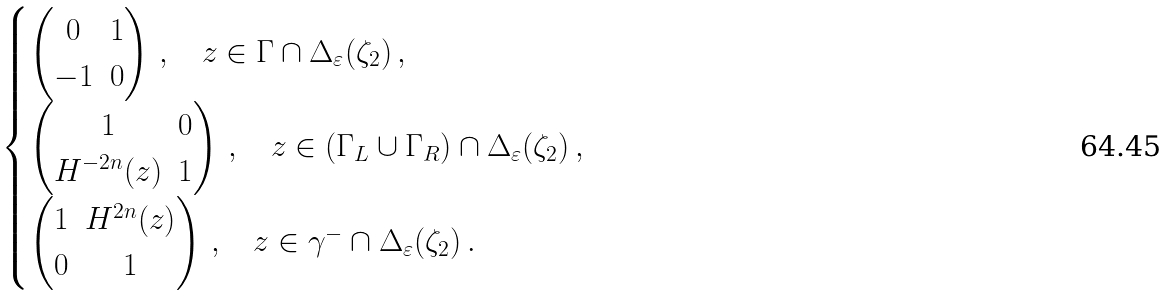Convert formula to latex. <formula><loc_0><loc_0><loc_500><loc_500>\begin{cases} \begin{pmatrix} 0 & 1 \\ - 1 & 0 \end{pmatrix} \, , \quad z \in \Gamma \cap \Delta _ { \varepsilon } ( \zeta _ { 2 } ) \, , \\ \begin{pmatrix} 1 & 0 \\ H ^ { - 2 n } ( z ) & 1 \end{pmatrix} \, , \quad z \in ( \Gamma _ { L } \cup \Gamma _ { R } ) \cap \Delta _ { \varepsilon } ( \zeta _ { 2 } ) \, , \\ \begin{pmatrix} 1 & H ^ { 2 n } ( z ) \\ 0 & 1 \end{pmatrix} \, , \quad z \in \gamma ^ { - } \cap \Delta _ { \varepsilon } ( \zeta _ { 2 } ) \, . \end{cases}</formula> 